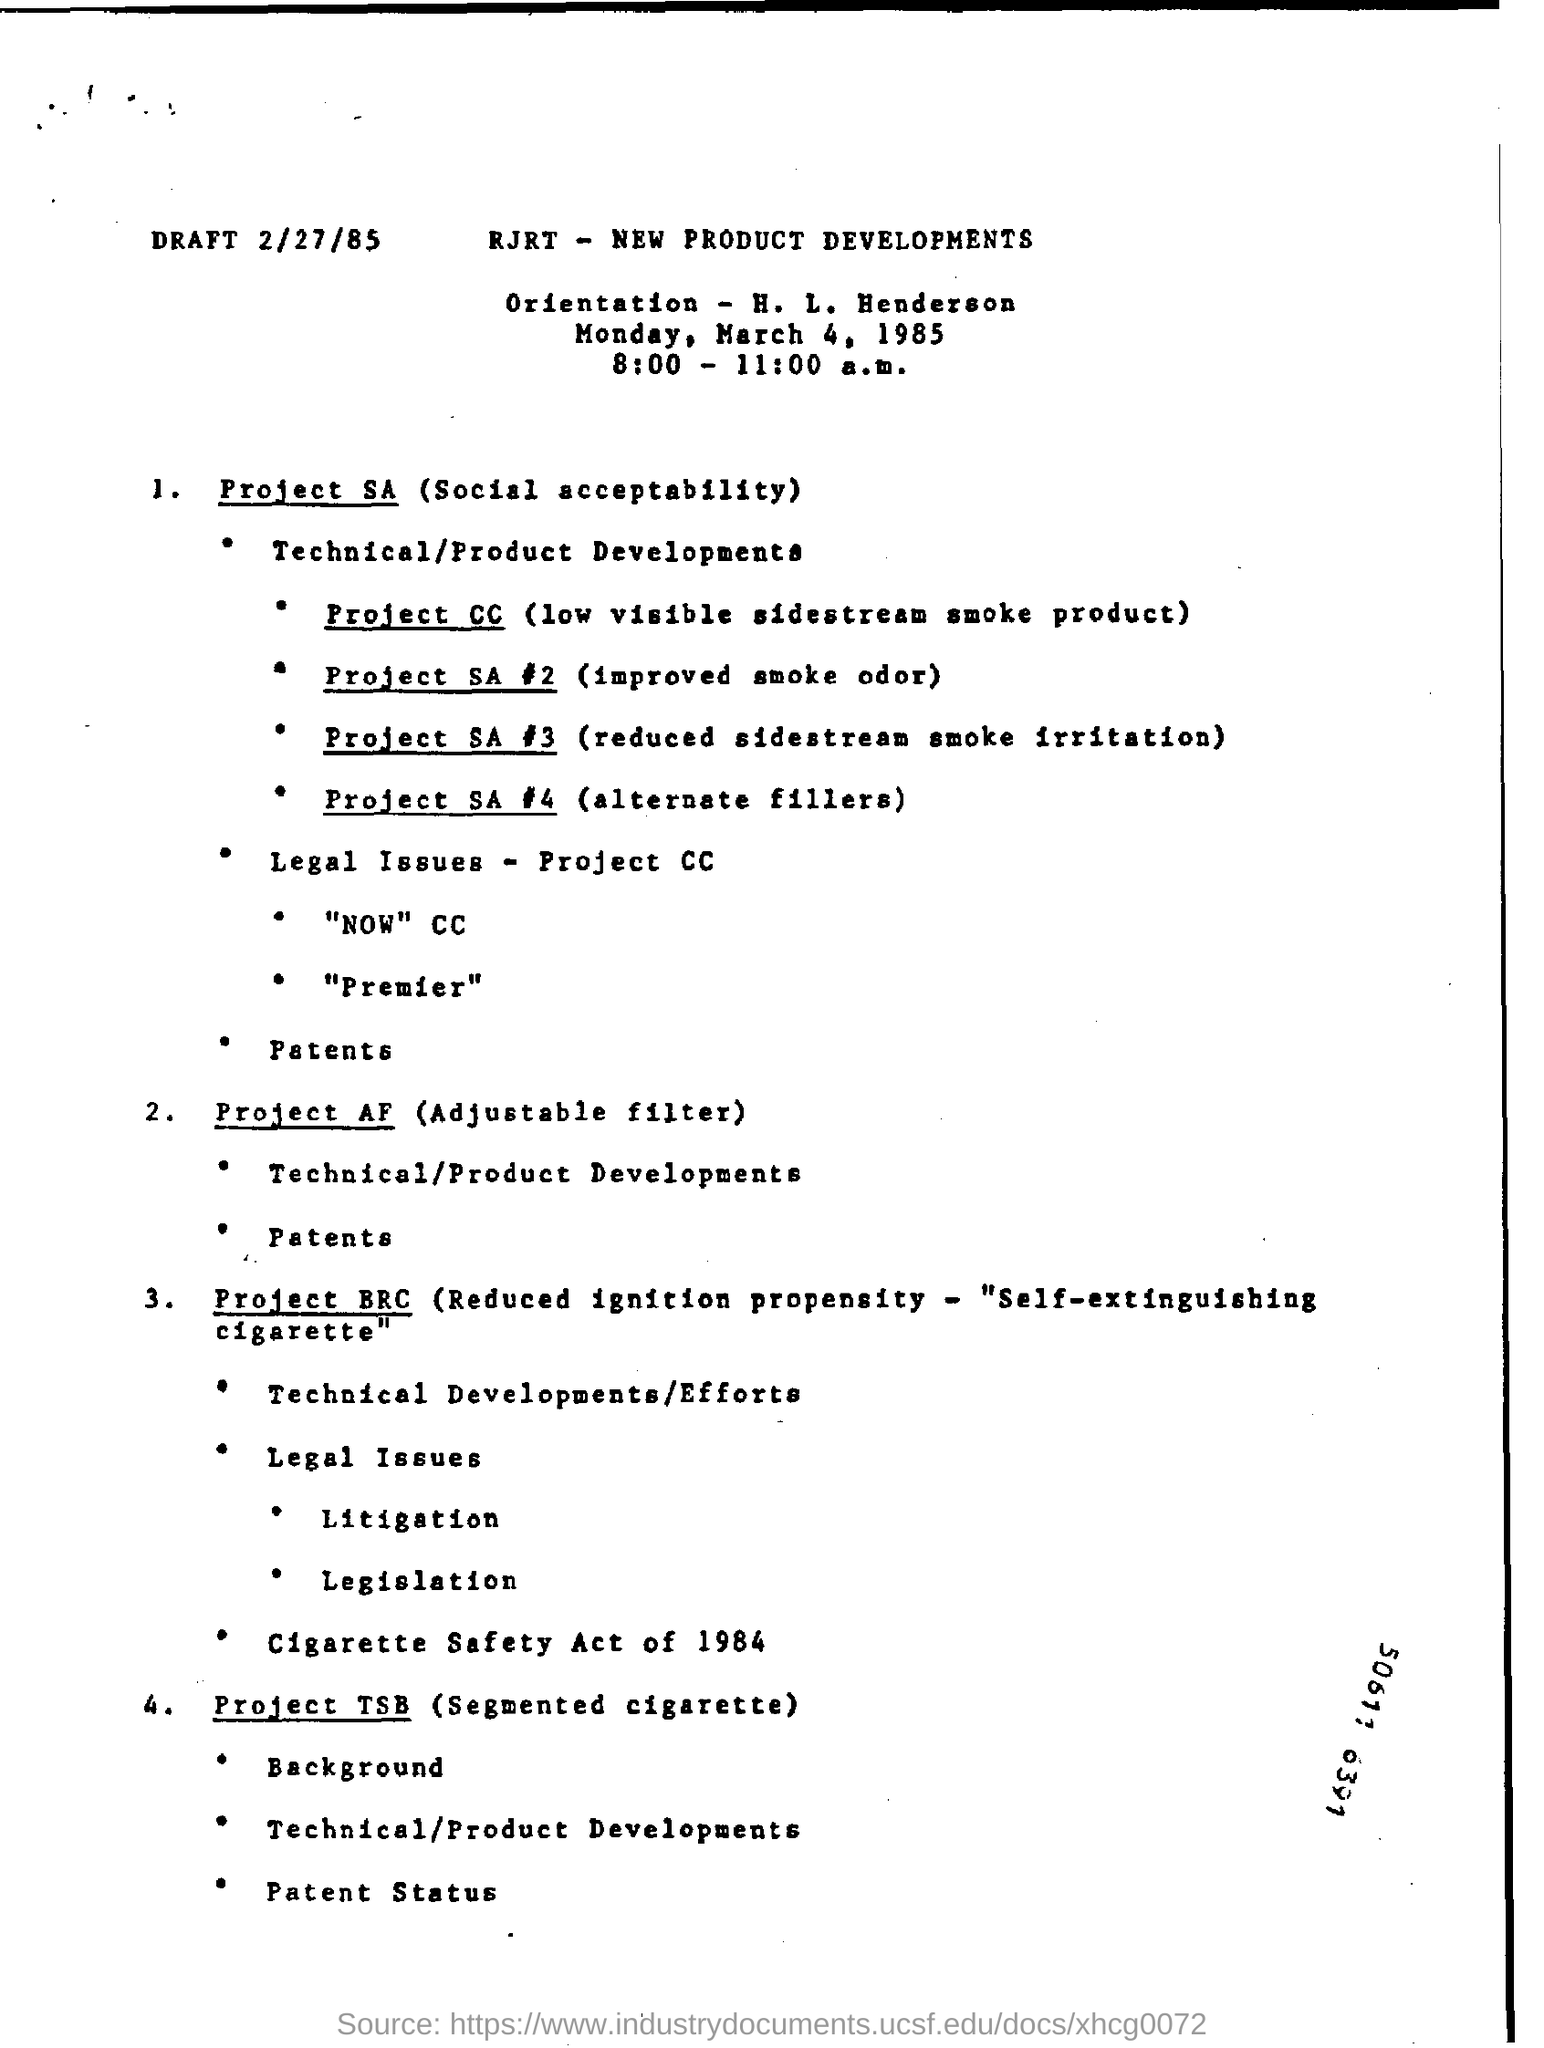What is the draft date?
Provide a short and direct response. 2/27/85. 